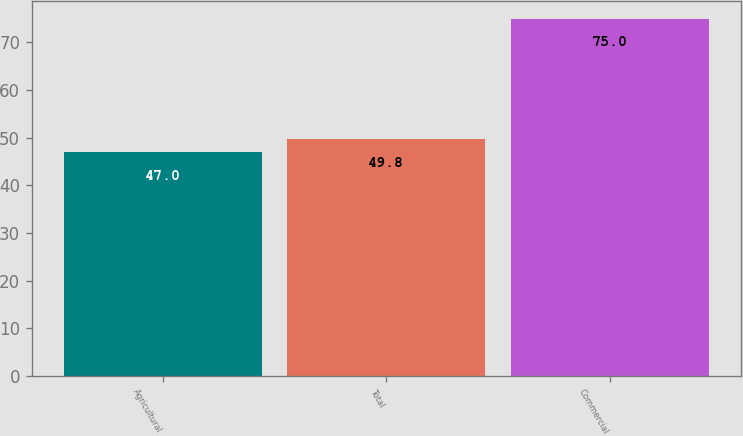<chart> <loc_0><loc_0><loc_500><loc_500><bar_chart><fcel>Agricultural<fcel>Total<fcel>Commercial<nl><fcel>47<fcel>49.8<fcel>75<nl></chart> 